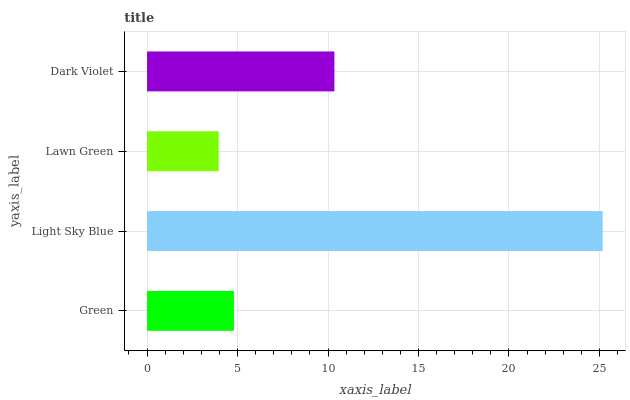Is Lawn Green the minimum?
Answer yes or no. Yes. Is Light Sky Blue the maximum?
Answer yes or no. Yes. Is Light Sky Blue the minimum?
Answer yes or no. No. Is Lawn Green the maximum?
Answer yes or no. No. Is Light Sky Blue greater than Lawn Green?
Answer yes or no. Yes. Is Lawn Green less than Light Sky Blue?
Answer yes or no. Yes. Is Lawn Green greater than Light Sky Blue?
Answer yes or no. No. Is Light Sky Blue less than Lawn Green?
Answer yes or no. No. Is Dark Violet the high median?
Answer yes or no. Yes. Is Green the low median?
Answer yes or no. Yes. Is Green the high median?
Answer yes or no. No. Is Light Sky Blue the low median?
Answer yes or no. No. 